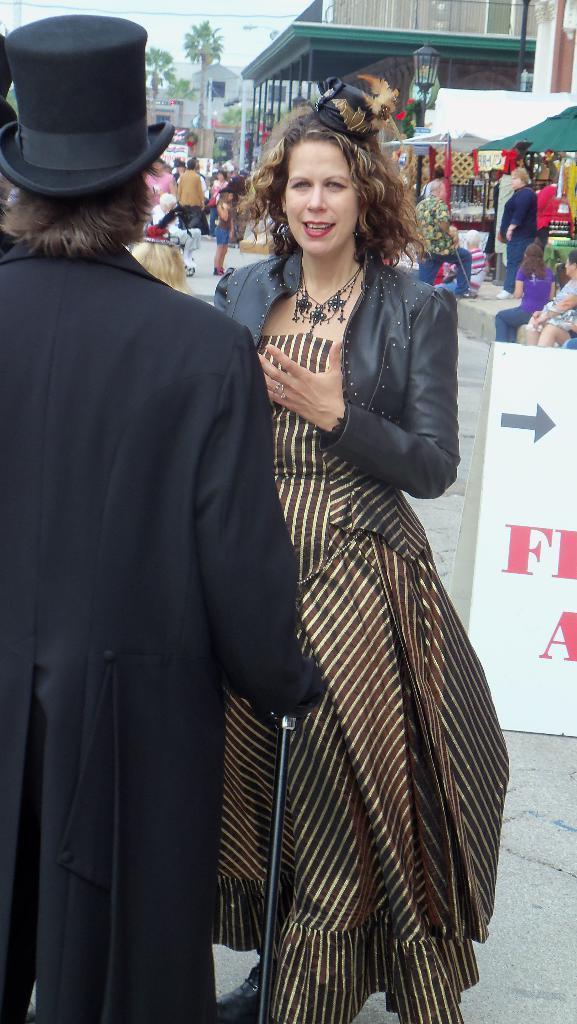Could you give a brief overview of what you see in this image? In this image in the foreground there are two persons standing, and one person is wearing a hat and holding a stick and another person is talking. And in the background there are a group of people, and there is one board. On the board there is text, and also in the background there are some buildings, trees, pole, light and some wires. At the bottom there is a walkway. 